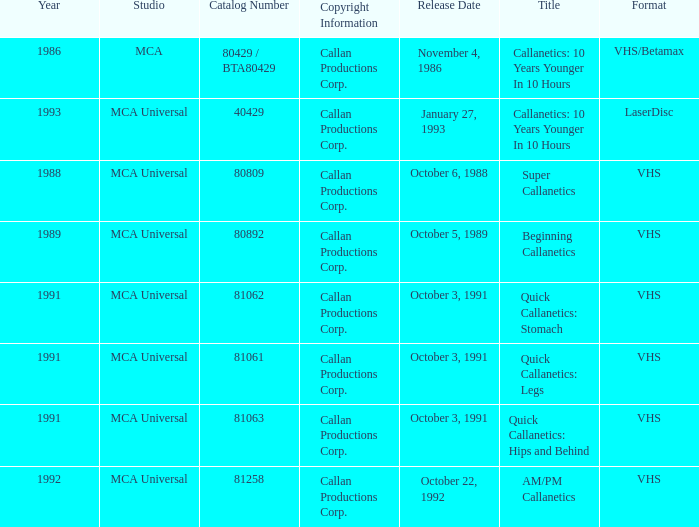Name the catalog number for  october 6, 1988 80809.0. 